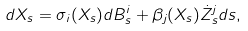Convert formula to latex. <formula><loc_0><loc_0><loc_500><loc_500>d X _ { s } = \sigma _ { i } ( X _ { s } ) d B ^ { i } _ { s } + \beta _ { j } ( X _ { s } ) \dot { Z } _ { s } ^ { j } d s ,</formula> 